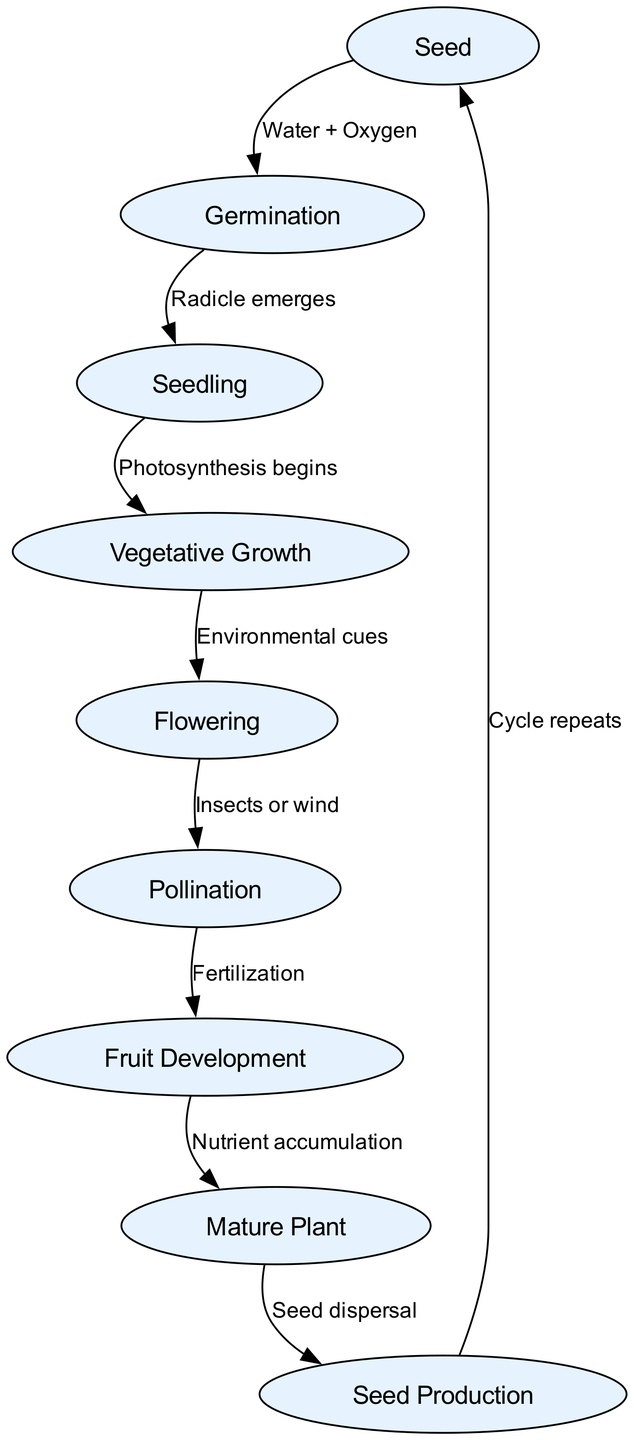What is the first stage in the plant life cycle? The diagram lists "Seed" as the first node, representing the initial stage of the plant life cycle.
Answer: Seed How many main stages are there in total? By counting the nodes, we identify 9 main stages in the diagram.
Answer: 9 What is required for the Germination process? The edge from "Seed" to "Germination" indicates that "Water + Oxygen" is necessary to initiate germination.
Answer: Water + Oxygen What emerges during the Germination stage? The transition from "Germination" to "Seedling" specifies that the "Radicle emerges" during this stage.
Answer: Radicle Which process follows Vegetative Growth? The flow from "Vegetative Growth" leads to "Flowering," indicating that flowering is the subsequent process.
Answer: Flowering What is the final outcome of the life cycle depicted in the diagram? The path from "Mature Plant" to "Seed Production" specifies that seeds are produced as the final outcome in the life cycle.
Answer: Seed Production What environmental factor triggers the transition to the Flowering stage? The transition from "Vegetative Growth" to "Flowering" is triggered by "Environmental cues," as indicated in the diagram.
Answer: Environmental cues Which stage is directly connected to Pollination? The diagram shows that "Flowering" directly leads to "Pollination," indicating this relationship.
Answer: Flowering What is the relationship between Fruit Development and the Mature Plant? The edge connects "Fruit Development" to "Mature Plant" and suggests this transition occurs after "Nutrient accumulation."
Answer: Nutrient accumulation 